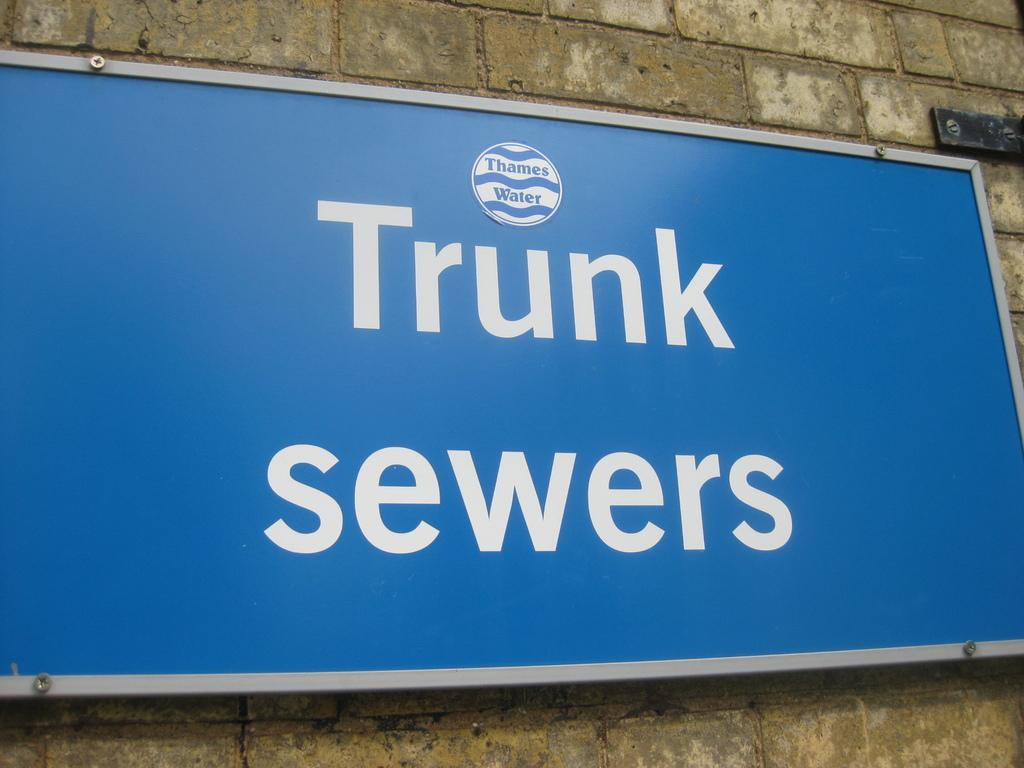<image>
Summarize the visual content of the image. A sign in white letters that reads Trunk Sewers hangs on the site of a wall. 